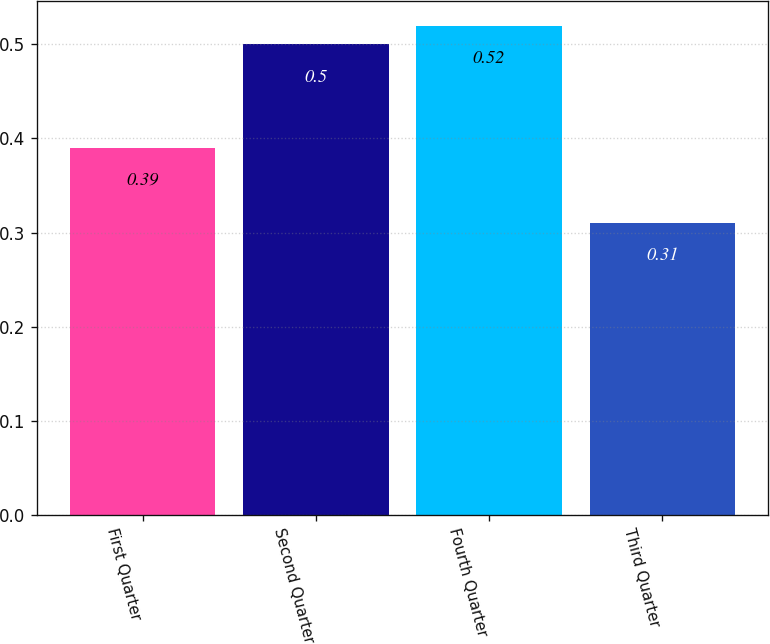Convert chart to OTSL. <chart><loc_0><loc_0><loc_500><loc_500><bar_chart><fcel>First Quarter<fcel>Second Quarter<fcel>Fourth Quarter<fcel>Third Quarter<nl><fcel>0.39<fcel>0.5<fcel>0.52<fcel>0.31<nl></chart> 